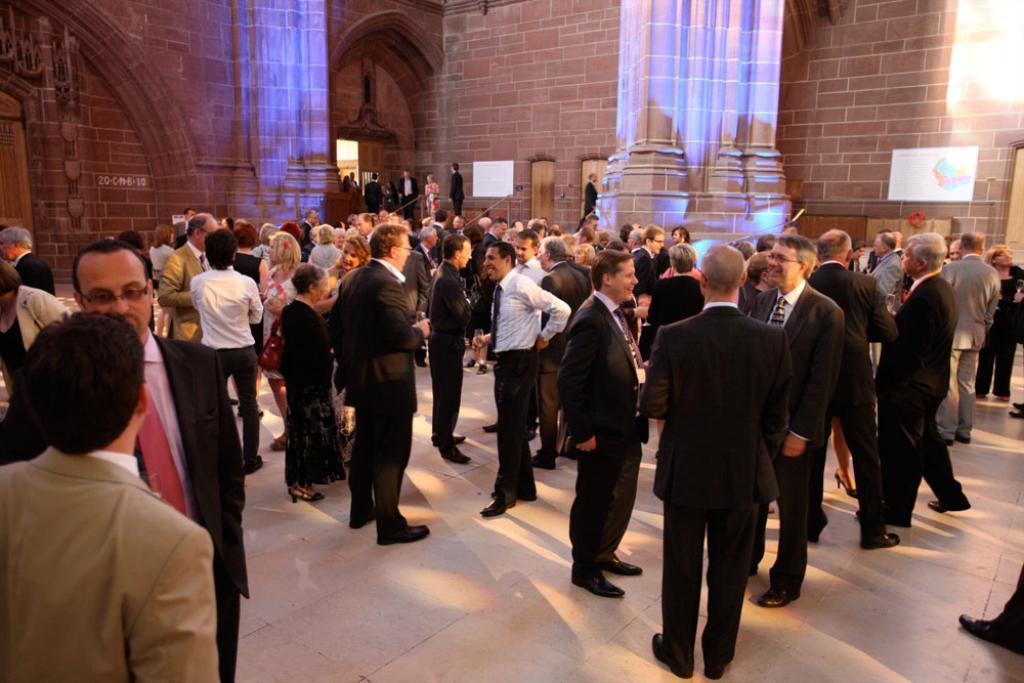In one or two sentences, can you explain what this image depicts? In this picture I can see so many people are in one place, around we can see some pillories and walls. 